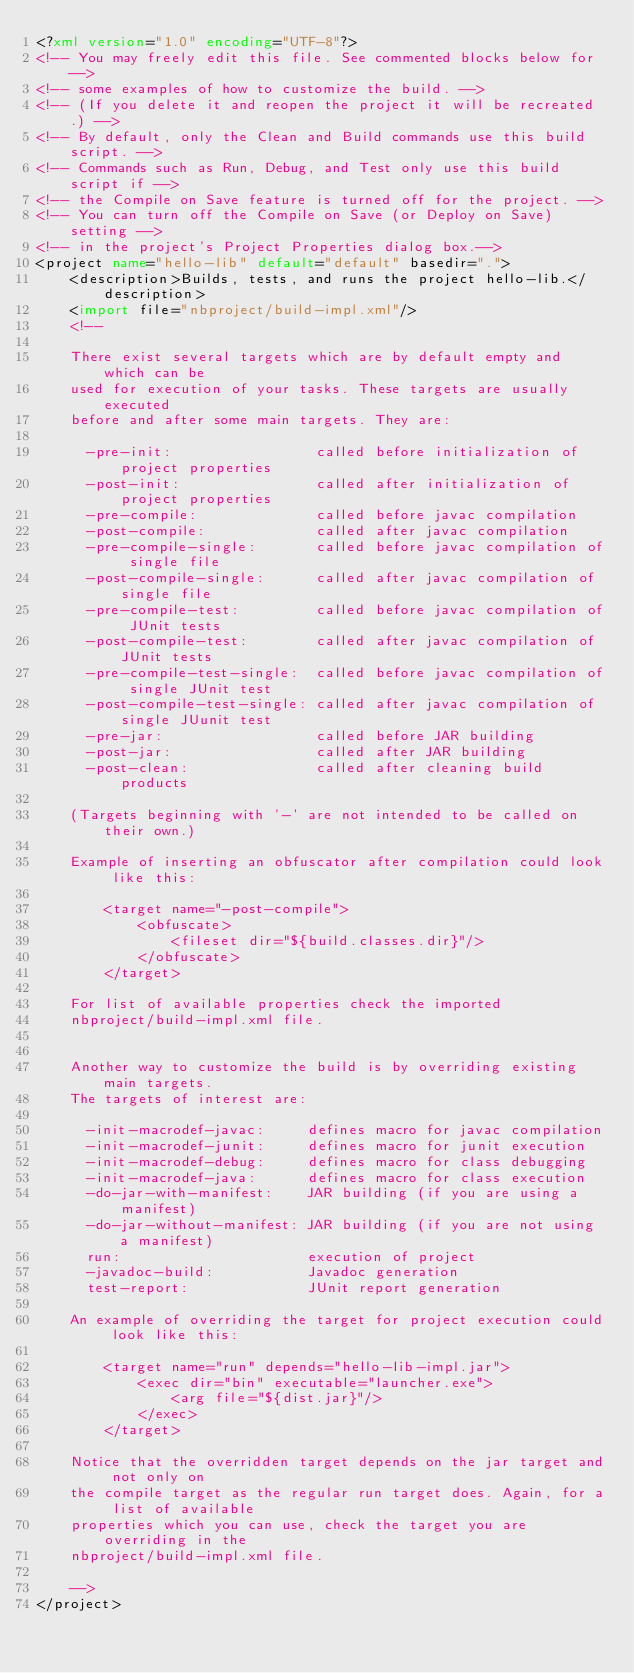Convert code to text. <code><loc_0><loc_0><loc_500><loc_500><_XML_><?xml version="1.0" encoding="UTF-8"?>
<!-- You may freely edit this file. See commented blocks below for -->
<!-- some examples of how to customize the build. -->
<!-- (If you delete it and reopen the project it will be recreated.) -->
<!-- By default, only the Clean and Build commands use this build script. -->
<!-- Commands such as Run, Debug, and Test only use this build script if -->
<!-- the Compile on Save feature is turned off for the project. -->
<!-- You can turn off the Compile on Save (or Deploy on Save) setting -->
<!-- in the project's Project Properties dialog box.-->
<project name="hello-lib" default="default" basedir=".">
    <description>Builds, tests, and runs the project hello-lib.</description>
    <import file="nbproject/build-impl.xml"/>
    <!--

    There exist several targets which are by default empty and which can be 
    used for execution of your tasks. These targets are usually executed 
    before and after some main targets. They are: 

      -pre-init:                 called before initialization of project properties
      -post-init:                called after initialization of project properties
      -pre-compile:              called before javac compilation
      -post-compile:             called after javac compilation
      -pre-compile-single:       called before javac compilation of single file
      -post-compile-single:      called after javac compilation of single file
      -pre-compile-test:         called before javac compilation of JUnit tests
      -post-compile-test:        called after javac compilation of JUnit tests
      -pre-compile-test-single:  called before javac compilation of single JUnit test
      -post-compile-test-single: called after javac compilation of single JUunit test
      -pre-jar:                  called before JAR building
      -post-jar:                 called after JAR building
      -post-clean:               called after cleaning build products

    (Targets beginning with '-' are not intended to be called on their own.)

    Example of inserting an obfuscator after compilation could look like this:

        <target name="-post-compile">
            <obfuscate>
                <fileset dir="${build.classes.dir}"/>
            </obfuscate>
        </target>

    For list of available properties check the imported 
    nbproject/build-impl.xml file. 


    Another way to customize the build is by overriding existing main targets.
    The targets of interest are: 

      -init-macrodef-javac:     defines macro for javac compilation
      -init-macrodef-junit:     defines macro for junit execution
      -init-macrodef-debug:     defines macro for class debugging
      -init-macrodef-java:      defines macro for class execution
      -do-jar-with-manifest:    JAR building (if you are using a manifest)
      -do-jar-without-manifest: JAR building (if you are not using a manifest)
      run:                      execution of project 
      -javadoc-build:           Javadoc generation
      test-report:              JUnit report generation

    An example of overriding the target for project execution could look like this:

        <target name="run" depends="hello-lib-impl.jar">
            <exec dir="bin" executable="launcher.exe">
                <arg file="${dist.jar}"/>
            </exec>
        </target>

    Notice that the overridden target depends on the jar target and not only on 
    the compile target as the regular run target does. Again, for a list of available 
    properties which you can use, check the target you are overriding in the
    nbproject/build-impl.xml file. 

    -->
</project>
</code> 